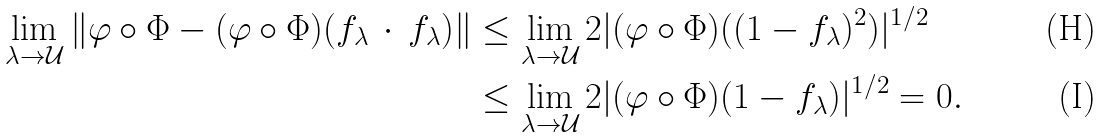<formula> <loc_0><loc_0><loc_500><loc_500>\lim _ { \lambda \to \mathcal { U } } \| \varphi \circ \Phi - ( \varphi \circ \Phi ) ( f _ { \lambda } \, \cdot \, f _ { \lambda } ) \| & \leq \lim _ { \lambda \to \mathcal { U } } 2 | ( \varphi \circ \Phi ) ( ( 1 - f _ { \lambda } ) ^ { 2 } ) | ^ { 1 / 2 } \\ & \leq \lim _ { \lambda \to \mathcal { U } } 2 | ( \varphi \circ \Phi ) ( 1 - f _ { \lambda } ) | ^ { 1 / 2 } = 0 .</formula> 